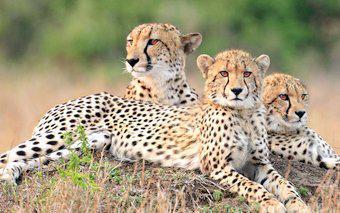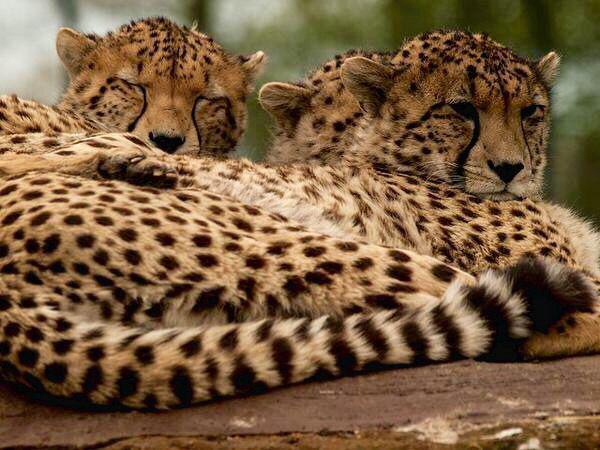The first image is the image on the left, the second image is the image on the right. Considering the images on both sides, is "There are more spotted wild cats in the left image than in the right." valid? Answer yes or no. No. The first image is the image on the left, the second image is the image on the right. Evaluate the accuracy of this statement regarding the images: "In one of the images, you can see one of the animal's tongues.". Is it true? Answer yes or no. No. 